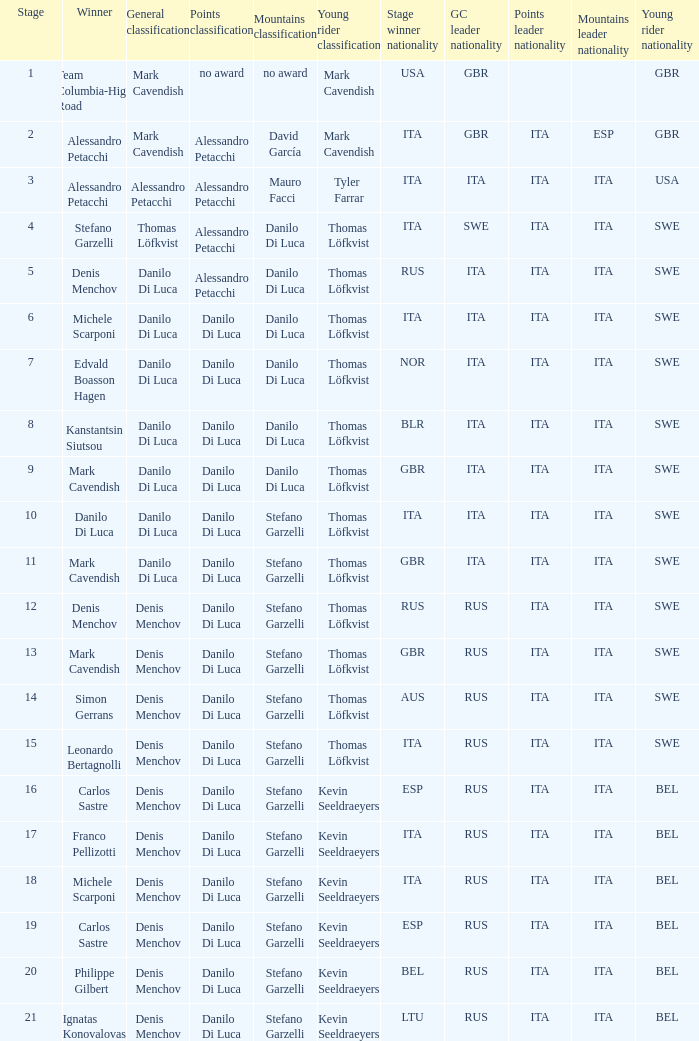When 19 is the stage who is the points classification? Danilo Di Luca. 